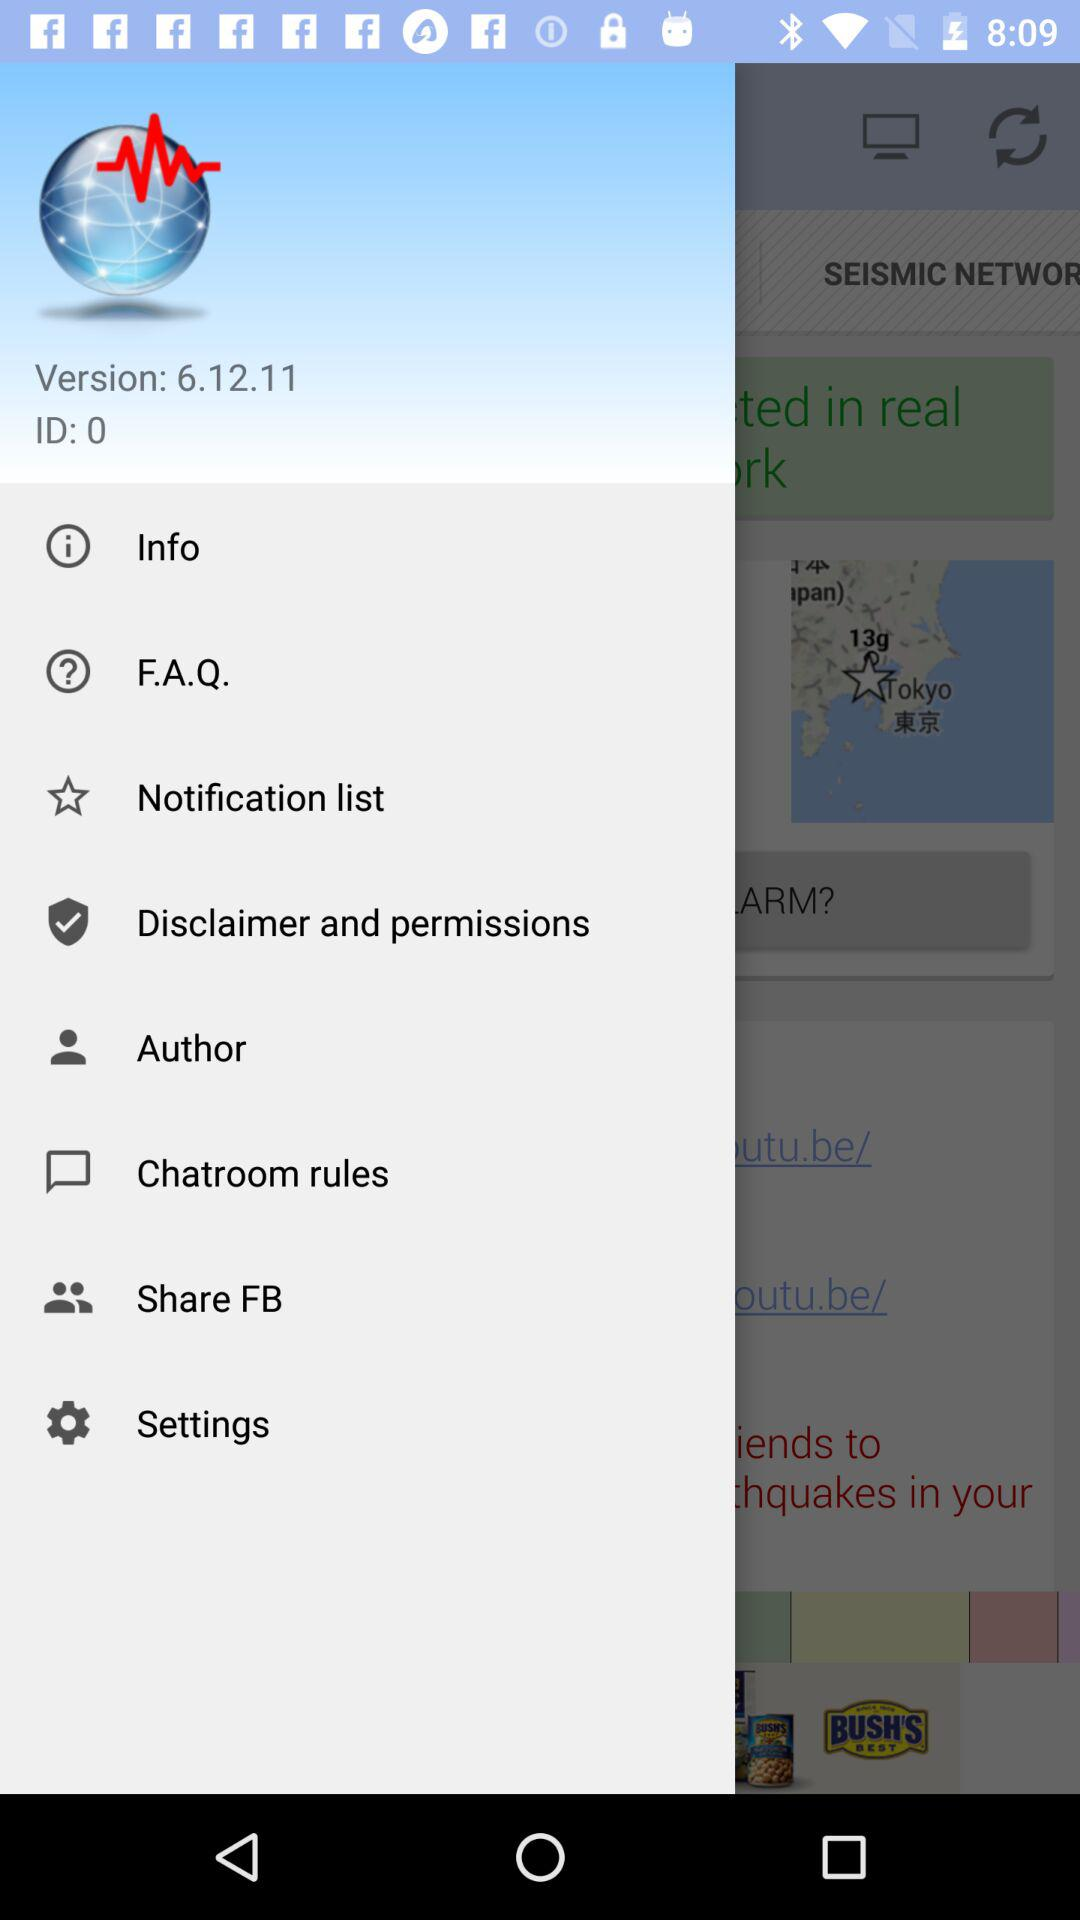Which version is used? The used version is 6.12.11. 